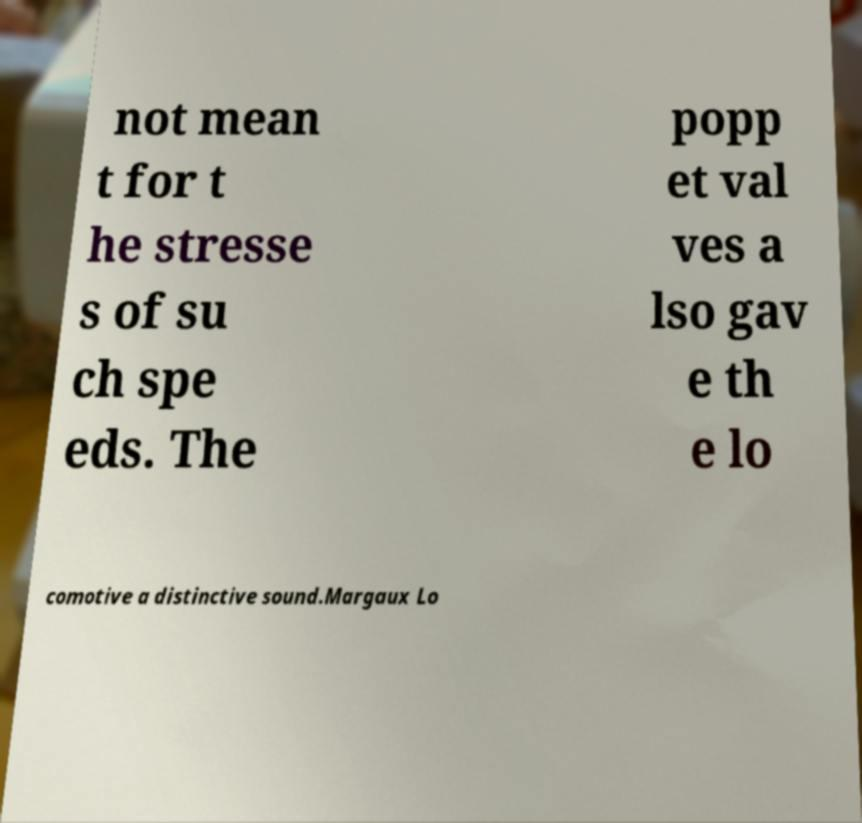What messages or text are displayed in this image? I need them in a readable, typed format. not mean t for t he stresse s of su ch spe eds. The popp et val ves a lso gav e th e lo comotive a distinctive sound.Margaux Lo 